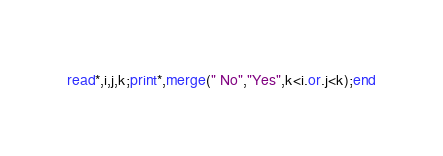Convert code to text. <code><loc_0><loc_0><loc_500><loc_500><_FORTRAN_>read*,i,j,k;print*,merge(" No","Yes",k<i.or.j<k);end</code> 